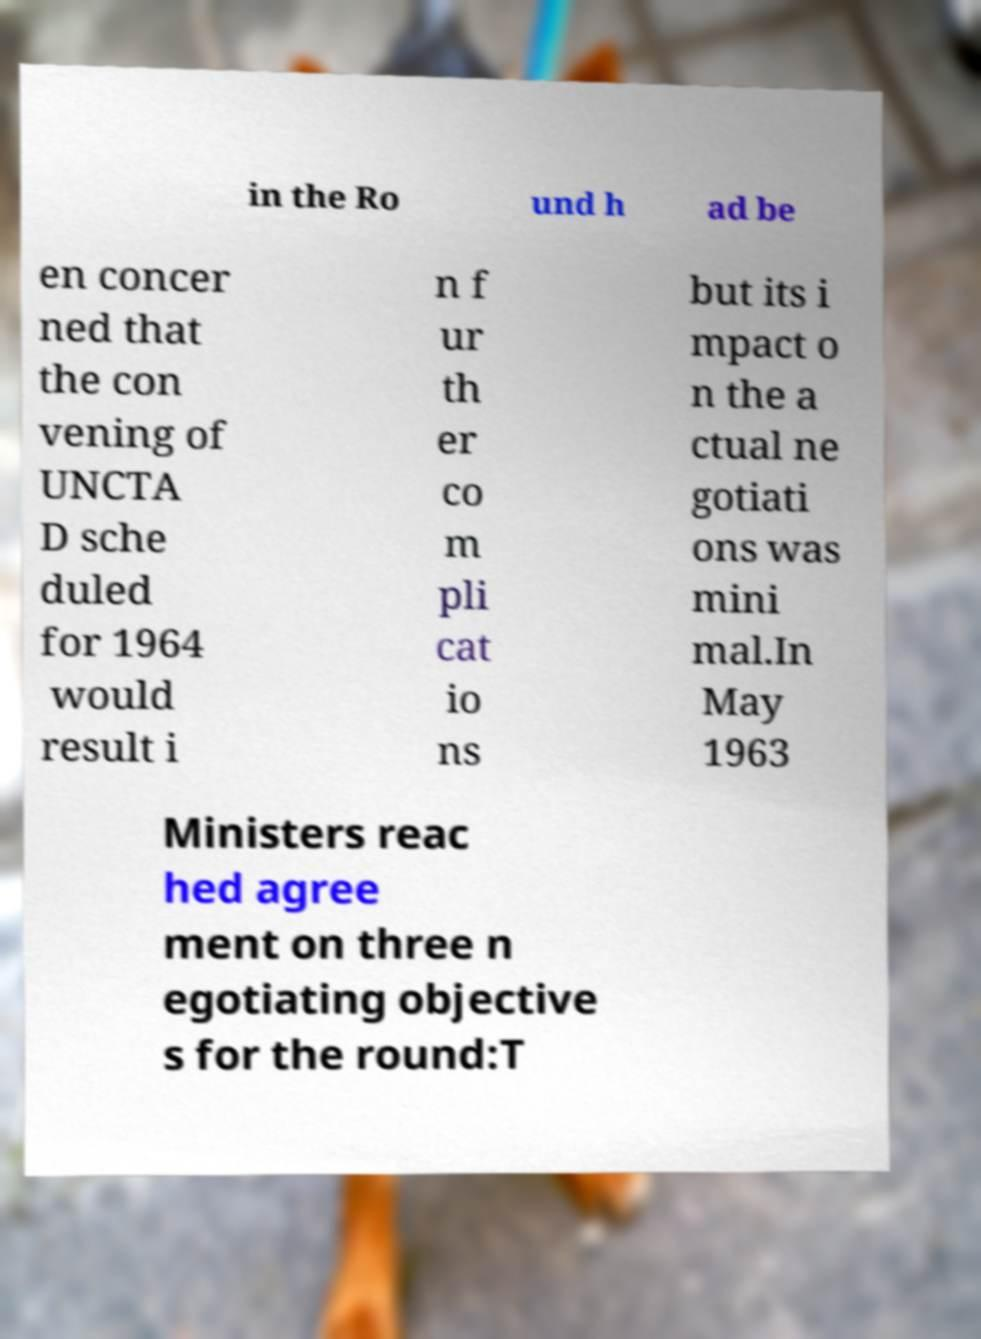For documentation purposes, I need the text within this image transcribed. Could you provide that? in the Ro und h ad be en concer ned that the con vening of UNCTA D sche duled for 1964 would result i n f ur th er co m pli cat io ns but its i mpact o n the a ctual ne gotiati ons was mini mal.In May 1963 Ministers reac hed agree ment on three n egotiating objective s for the round:T 